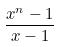<formula> <loc_0><loc_0><loc_500><loc_500>\frac { x ^ { n } - 1 } { x - 1 }</formula> 